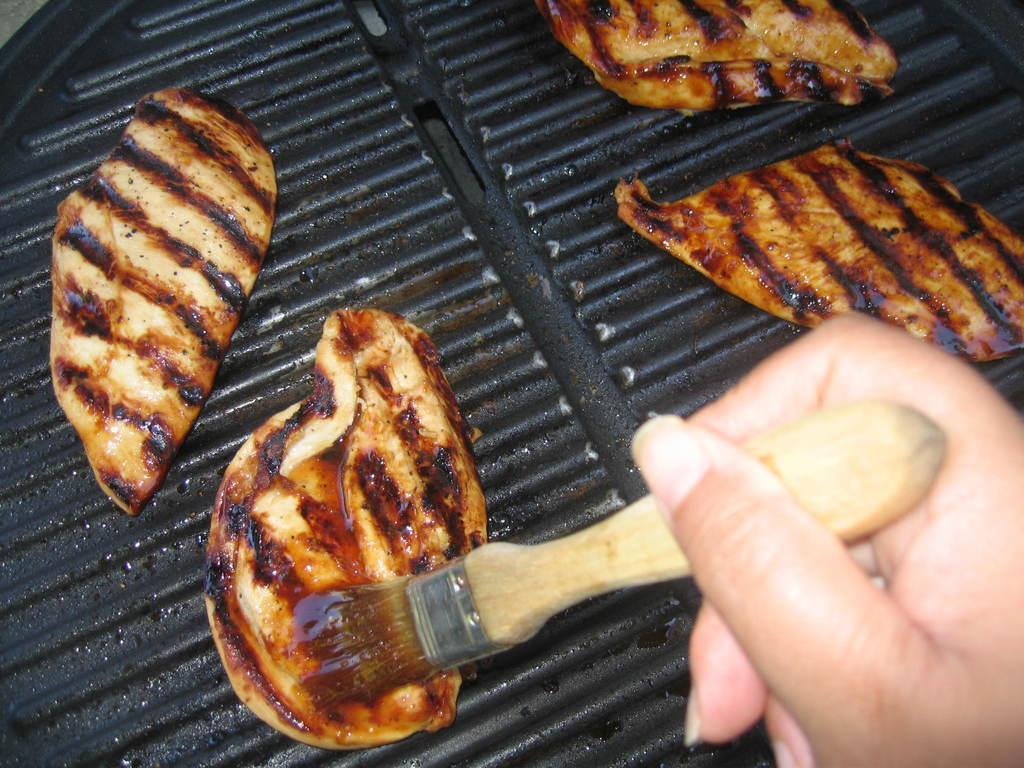Can you describe this image briefly? In this image, we can see a black color grill and there are some food items on the grill, we can see the hand of a person holding a brush. 